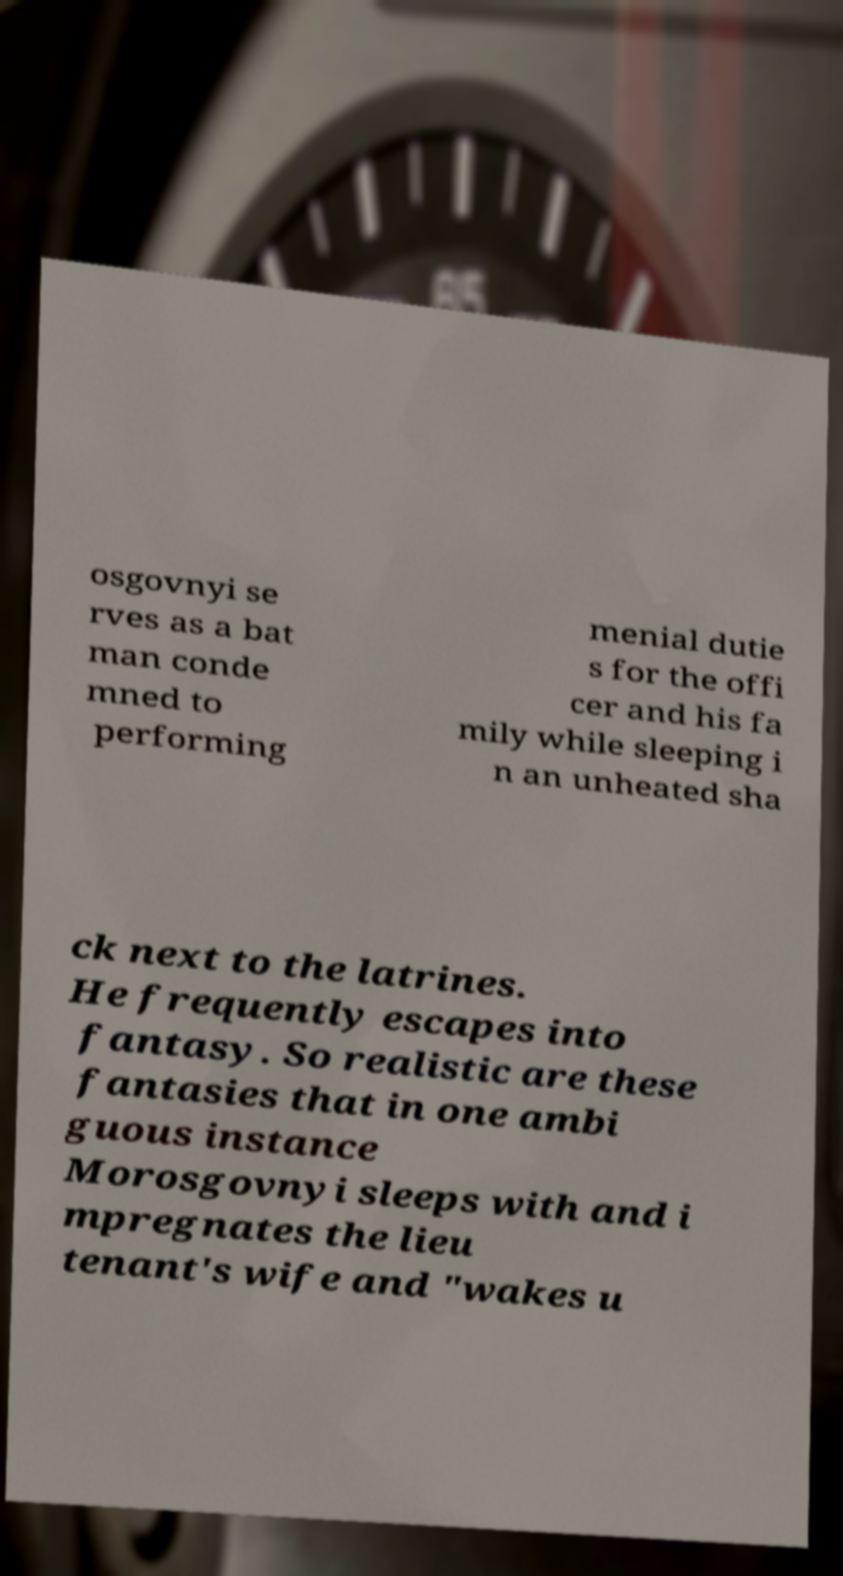There's text embedded in this image that I need extracted. Can you transcribe it verbatim? osgovnyi se rves as a bat man conde mned to performing menial dutie s for the offi cer and his fa mily while sleeping i n an unheated sha ck next to the latrines. He frequently escapes into fantasy. So realistic are these fantasies that in one ambi guous instance Morosgovnyi sleeps with and i mpregnates the lieu tenant's wife and "wakes u 